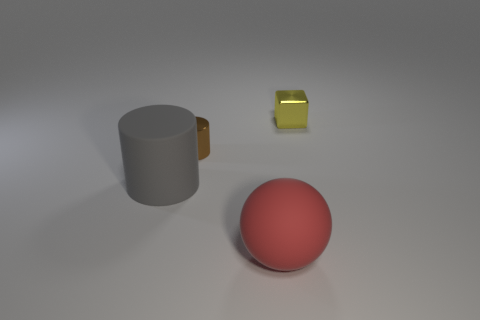There is a gray object that is the same size as the red matte sphere; what is its shape?
Provide a short and direct response. Cylinder. There is a thing that is the same material as the large gray cylinder; what size is it?
Provide a short and direct response. Large. Does the big gray rubber thing have the same shape as the tiny brown thing?
Keep it short and to the point. Yes. There is a cylinder that is the same size as the red ball; what color is it?
Your response must be concise. Gray. The brown thing that is the same shape as the large gray thing is what size?
Make the answer very short. Small. There is a matte object behind the big red thing; what is its shape?
Your answer should be very brief. Cylinder. There is a red object; is its shape the same as the big object that is behind the red sphere?
Give a very brief answer. No. Are there the same number of small brown cylinders on the left side of the gray matte cylinder and metal blocks behind the red matte object?
Your response must be concise. No. Are there more small brown metal things on the left side of the yellow object than large cyan cylinders?
Give a very brief answer. Yes. What is the material of the big gray cylinder?
Your answer should be very brief. Rubber. 